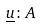<formula> <loc_0><loc_0><loc_500><loc_500>\underline { u } \colon A</formula> 